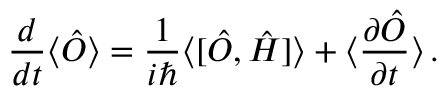<formula> <loc_0><loc_0><loc_500><loc_500>\frac { d } { d t } \langle \hat { O } \rangle = \frac { 1 } { i } \langle [ \hat { O } , \hat { H } ] \rangle + \langle \frac { \partial \hat { O } } { \partial t } \rangle \, .</formula> 